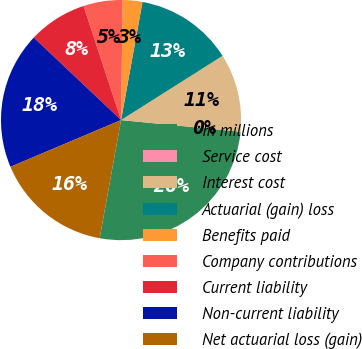<chart> <loc_0><loc_0><loc_500><loc_500><pie_chart><fcel>In millions<fcel>Service cost<fcel>Interest cost<fcel>Actuarial (gain) loss<fcel>Benefits paid<fcel>Company contributions<fcel>Current liability<fcel>Non-current liability<fcel>Net actuarial loss (gain)<nl><fcel>26.3%<fcel>0.01%<fcel>10.53%<fcel>13.16%<fcel>2.64%<fcel>5.27%<fcel>7.9%<fcel>18.41%<fcel>15.78%<nl></chart> 